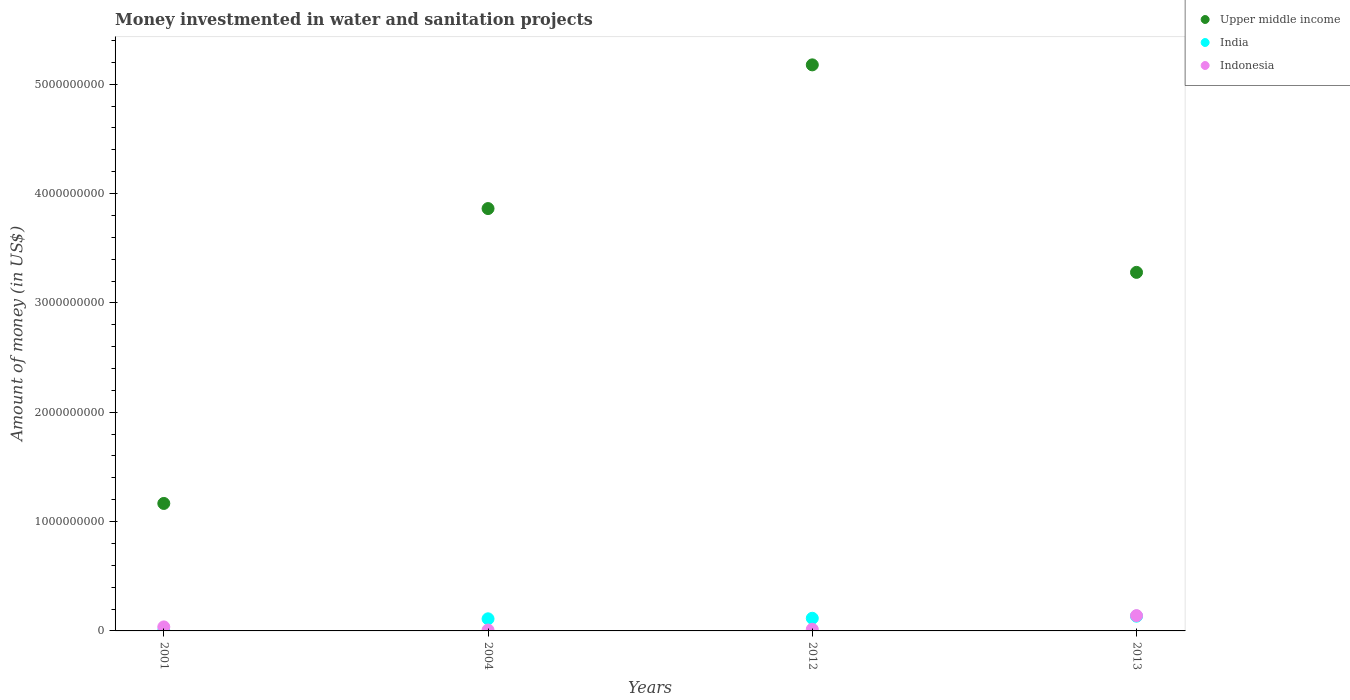How many different coloured dotlines are there?
Offer a very short reply. 3. Is the number of dotlines equal to the number of legend labels?
Your answer should be very brief. Yes. What is the money investmented in water and sanitation projects in India in 2001?
Offer a very short reply. 2.10e+06. Across all years, what is the maximum money investmented in water and sanitation projects in India?
Keep it short and to the point. 1.35e+08. Across all years, what is the minimum money investmented in water and sanitation projects in Upper middle income?
Keep it short and to the point. 1.17e+09. In which year was the money investmented in water and sanitation projects in Indonesia minimum?
Keep it short and to the point. 2004. What is the total money investmented in water and sanitation projects in Indonesia in the graph?
Ensure brevity in your answer.  2.00e+08. What is the difference between the money investmented in water and sanitation projects in Indonesia in 2012 and that in 2013?
Give a very brief answer. -1.25e+08. What is the difference between the money investmented in water and sanitation projects in India in 2004 and the money investmented in water and sanitation projects in Indonesia in 2012?
Your answer should be very brief. 9.58e+07. What is the average money investmented in water and sanitation projects in India per year?
Your answer should be very brief. 9.09e+07. In the year 2013, what is the difference between the money investmented in water and sanitation projects in India and money investmented in water and sanitation projects in Indonesia?
Ensure brevity in your answer.  -4.90e+06. In how many years, is the money investmented in water and sanitation projects in India greater than 2600000000 US$?
Provide a succinct answer. 0. What is the ratio of the money investmented in water and sanitation projects in India in 2004 to that in 2012?
Offer a terse response. 0.96. Is the difference between the money investmented in water and sanitation projects in India in 2001 and 2012 greater than the difference between the money investmented in water and sanitation projects in Indonesia in 2001 and 2012?
Your answer should be very brief. No. What is the difference between the highest and the second highest money investmented in water and sanitation projects in India?
Give a very brief answer. 1.95e+07. What is the difference between the highest and the lowest money investmented in water and sanitation projects in India?
Give a very brief answer. 1.33e+08. Is the sum of the money investmented in water and sanitation projects in Upper middle income in 2004 and 2013 greater than the maximum money investmented in water and sanitation projects in Indonesia across all years?
Provide a succinct answer. Yes. Does the money investmented in water and sanitation projects in Indonesia monotonically increase over the years?
Make the answer very short. No. Is the money investmented in water and sanitation projects in India strictly greater than the money investmented in water and sanitation projects in Indonesia over the years?
Your answer should be very brief. No. Is the money investmented in water and sanitation projects in India strictly less than the money investmented in water and sanitation projects in Indonesia over the years?
Ensure brevity in your answer.  No. How many dotlines are there?
Provide a short and direct response. 3. How many years are there in the graph?
Offer a terse response. 4. Are the values on the major ticks of Y-axis written in scientific E-notation?
Your response must be concise. No. Does the graph contain grids?
Offer a terse response. No. What is the title of the graph?
Your response must be concise. Money investmented in water and sanitation projects. Does "Honduras" appear as one of the legend labels in the graph?
Your response must be concise. No. What is the label or title of the Y-axis?
Your response must be concise. Amount of money (in US$). What is the Amount of money (in US$) of Upper middle income in 2001?
Your response must be concise. 1.17e+09. What is the Amount of money (in US$) in India in 2001?
Make the answer very short. 2.10e+06. What is the Amount of money (in US$) of Indonesia in 2001?
Make the answer very short. 3.67e+07. What is the Amount of money (in US$) in Upper middle income in 2004?
Keep it short and to the point. 3.86e+09. What is the Amount of money (in US$) of India in 2004?
Your answer should be compact. 1.11e+08. What is the Amount of money (in US$) of Indonesia in 2004?
Your answer should be compact. 8.10e+06. What is the Amount of money (in US$) of Upper middle income in 2012?
Your answer should be very brief. 5.18e+09. What is the Amount of money (in US$) of India in 2012?
Keep it short and to the point. 1.16e+08. What is the Amount of money (in US$) of Indonesia in 2012?
Your response must be concise. 1.50e+07. What is the Amount of money (in US$) of Upper middle income in 2013?
Make the answer very short. 3.28e+09. What is the Amount of money (in US$) in India in 2013?
Your answer should be very brief. 1.35e+08. What is the Amount of money (in US$) in Indonesia in 2013?
Make the answer very short. 1.40e+08. Across all years, what is the maximum Amount of money (in US$) in Upper middle income?
Offer a very short reply. 5.18e+09. Across all years, what is the maximum Amount of money (in US$) in India?
Your answer should be very brief. 1.35e+08. Across all years, what is the maximum Amount of money (in US$) of Indonesia?
Provide a succinct answer. 1.40e+08. Across all years, what is the minimum Amount of money (in US$) in Upper middle income?
Your response must be concise. 1.17e+09. Across all years, what is the minimum Amount of money (in US$) in India?
Make the answer very short. 2.10e+06. Across all years, what is the minimum Amount of money (in US$) in Indonesia?
Provide a short and direct response. 8.10e+06. What is the total Amount of money (in US$) of Upper middle income in the graph?
Offer a very short reply. 1.35e+1. What is the total Amount of money (in US$) of India in the graph?
Give a very brief answer. 3.64e+08. What is the total Amount of money (in US$) in Indonesia in the graph?
Your response must be concise. 2.00e+08. What is the difference between the Amount of money (in US$) of Upper middle income in 2001 and that in 2004?
Provide a short and direct response. -2.70e+09. What is the difference between the Amount of money (in US$) of India in 2001 and that in 2004?
Keep it short and to the point. -1.09e+08. What is the difference between the Amount of money (in US$) in Indonesia in 2001 and that in 2004?
Provide a succinct answer. 2.86e+07. What is the difference between the Amount of money (in US$) in Upper middle income in 2001 and that in 2012?
Your answer should be very brief. -4.01e+09. What is the difference between the Amount of money (in US$) of India in 2001 and that in 2012?
Offer a terse response. -1.14e+08. What is the difference between the Amount of money (in US$) of Indonesia in 2001 and that in 2012?
Offer a terse response. 2.17e+07. What is the difference between the Amount of money (in US$) in Upper middle income in 2001 and that in 2013?
Give a very brief answer. -2.11e+09. What is the difference between the Amount of money (in US$) of India in 2001 and that in 2013?
Your answer should be compact. -1.33e+08. What is the difference between the Amount of money (in US$) of Indonesia in 2001 and that in 2013?
Make the answer very short. -1.03e+08. What is the difference between the Amount of money (in US$) in Upper middle income in 2004 and that in 2012?
Ensure brevity in your answer.  -1.31e+09. What is the difference between the Amount of money (in US$) in India in 2004 and that in 2012?
Provide a short and direct response. -4.85e+06. What is the difference between the Amount of money (in US$) of Indonesia in 2004 and that in 2012?
Provide a succinct answer. -6.90e+06. What is the difference between the Amount of money (in US$) in Upper middle income in 2004 and that in 2013?
Your response must be concise. 5.83e+08. What is the difference between the Amount of money (in US$) of India in 2004 and that in 2013?
Ensure brevity in your answer.  -2.44e+07. What is the difference between the Amount of money (in US$) in Indonesia in 2004 and that in 2013?
Offer a terse response. -1.32e+08. What is the difference between the Amount of money (in US$) of Upper middle income in 2012 and that in 2013?
Provide a succinct answer. 1.90e+09. What is the difference between the Amount of money (in US$) in India in 2012 and that in 2013?
Your response must be concise. -1.95e+07. What is the difference between the Amount of money (in US$) in Indonesia in 2012 and that in 2013?
Offer a very short reply. -1.25e+08. What is the difference between the Amount of money (in US$) in Upper middle income in 2001 and the Amount of money (in US$) in India in 2004?
Keep it short and to the point. 1.06e+09. What is the difference between the Amount of money (in US$) in Upper middle income in 2001 and the Amount of money (in US$) in Indonesia in 2004?
Your response must be concise. 1.16e+09. What is the difference between the Amount of money (in US$) in India in 2001 and the Amount of money (in US$) in Indonesia in 2004?
Make the answer very short. -6.00e+06. What is the difference between the Amount of money (in US$) in Upper middle income in 2001 and the Amount of money (in US$) in India in 2012?
Provide a short and direct response. 1.05e+09. What is the difference between the Amount of money (in US$) of Upper middle income in 2001 and the Amount of money (in US$) of Indonesia in 2012?
Offer a terse response. 1.15e+09. What is the difference between the Amount of money (in US$) of India in 2001 and the Amount of money (in US$) of Indonesia in 2012?
Keep it short and to the point. -1.29e+07. What is the difference between the Amount of money (in US$) of Upper middle income in 2001 and the Amount of money (in US$) of India in 2013?
Keep it short and to the point. 1.03e+09. What is the difference between the Amount of money (in US$) of Upper middle income in 2001 and the Amount of money (in US$) of Indonesia in 2013?
Offer a terse response. 1.03e+09. What is the difference between the Amount of money (in US$) of India in 2001 and the Amount of money (in US$) of Indonesia in 2013?
Make the answer very short. -1.38e+08. What is the difference between the Amount of money (in US$) in Upper middle income in 2004 and the Amount of money (in US$) in India in 2012?
Offer a terse response. 3.75e+09. What is the difference between the Amount of money (in US$) in Upper middle income in 2004 and the Amount of money (in US$) in Indonesia in 2012?
Offer a terse response. 3.85e+09. What is the difference between the Amount of money (in US$) of India in 2004 and the Amount of money (in US$) of Indonesia in 2012?
Make the answer very short. 9.58e+07. What is the difference between the Amount of money (in US$) of Upper middle income in 2004 and the Amount of money (in US$) of India in 2013?
Your answer should be compact. 3.73e+09. What is the difference between the Amount of money (in US$) in Upper middle income in 2004 and the Amount of money (in US$) in Indonesia in 2013?
Your answer should be compact. 3.72e+09. What is the difference between the Amount of money (in US$) of India in 2004 and the Amount of money (in US$) of Indonesia in 2013?
Give a very brief answer. -2.92e+07. What is the difference between the Amount of money (in US$) in Upper middle income in 2012 and the Amount of money (in US$) in India in 2013?
Your answer should be compact. 5.04e+09. What is the difference between the Amount of money (in US$) in Upper middle income in 2012 and the Amount of money (in US$) in Indonesia in 2013?
Make the answer very short. 5.04e+09. What is the difference between the Amount of money (in US$) in India in 2012 and the Amount of money (in US$) in Indonesia in 2013?
Give a very brief answer. -2.44e+07. What is the average Amount of money (in US$) of Upper middle income per year?
Give a very brief answer. 3.37e+09. What is the average Amount of money (in US$) in India per year?
Your response must be concise. 9.09e+07. What is the average Amount of money (in US$) in Indonesia per year?
Offer a very short reply. 5.00e+07. In the year 2001, what is the difference between the Amount of money (in US$) of Upper middle income and Amount of money (in US$) of India?
Your answer should be very brief. 1.16e+09. In the year 2001, what is the difference between the Amount of money (in US$) in Upper middle income and Amount of money (in US$) in Indonesia?
Offer a very short reply. 1.13e+09. In the year 2001, what is the difference between the Amount of money (in US$) of India and Amount of money (in US$) of Indonesia?
Your answer should be compact. -3.46e+07. In the year 2004, what is the difference between the Amount of money (in US$) of Upper middle income and Amount of money (in US$) of India?
Your response must be concise. 3.75e+09. In the year 2004, what is the difference between the Amount of money (in US$) of Upper middle income and Amount of money (in US$) of Indonesia?
Give a very brief answer. 3.85e+09. In the year 2004, what is the difference between the Amount of money (in US$) of India and Amount of money (in US$) of Indonesia?
Provide a succinct answer. 1.03e+08. In the year 2012, what is the difference between the Amount of money (in US$) of Upper middle income and Amount of money (in US$) of India?
Provide a short and direct response. 5.06e+09. In the year 2012, what is the difference between the Amount of money (in US$) of Upper middle income and Amount of money (in US$) of Indonesia?
Offer a very short reply. 5.16e+09. In the year 2012, what is the difference between the Amount of money (in US$) in India and Amount of money (in US$) in Indonesia?
Give a very brief answer. 1.01e+08. In the year 2013, what is the difference between the Amount of money (in US$) of Upper middle income and Amount of money (in US$) of India?
Provide a succinct answer. 3.14e+09. In the year 2013, what is the difference between the Amount of money (in US$) in Upper middle income and Amount of money (in US$) in Indonesia?
Make the answer very short. 3.14e+09. In the year 2013, what is the difference between the Amount of money (in US$) in India and Amount of money (in US$) in Indonesia?
Offer a very short reply. -4.90e+06. What is the ratio of the Amount of money (in US$) in Upper middle income in 2001 to that in 2004?
Your answer should be compact. 0.3. What is the ratio of the Amount of money (in US$) of India in 2001 to that in 2004?
Your response must be concise. 0.02. What is the ratio of the Amount of money (in US$) of Indonesia in 2001 to that in 2004?
Provide a succinct answer. 4.53. What is the ratio of the Amount of money (in US$) of Upper middle income in 2001 to that in 2012?
Offer a terse response. 0.23. What is the ratio of the Amount of money (in US$) of India in 2001 to that in 2012?
Offer a very short reply. 0.02. What is the ratio of the Amount of money (in US$) in Indonesia in 2001 to that in 2012?
Keep it short and to the point. 2.45. What is the ratio of the Amount of money (in US$) of Upper middle income in 2001 to that in 2013?
Your answer should be compact. 0.36. What is the ratio of the Amount of money (in US$) of India in 2001 to that in 2013?
Ensure brevity in your answer.  0.02. What is the ratio of the Amount of money (in US$) of Indonesia in 2001 to that in 2013?
Ensure brevity in your answer.  0.26. What is the ratio of the Amount of money (in US$) in Upper middle income in 2004 to that in 2012?
Offer a very short reply. 0.75. What is the ratio of the Amount of money (in US$) of India in 2004 to that in 2012?
Give a very brief answer. 0.96. What is the ratio of the Amount of money (in US$) of Indonesia in 2004 to that in 2012?
Offer a very short reply. 0.54. What is the ratio of the Amount of money (in US$) of Upper middle income in 2004 to that in 2013?
Your response must be concise. 1.18. What is the ratio of the Amount of money (in US$) in India in 2004 to that in 2013?
Give a very brief answer. 0.82. What is the ratio of the Amount of money (in US$) of Indonesia in 2004 to that in 2013?
Keep it short and to the point. 0.06. What is the ratio of the Amount of money (in US$) in Upper middle income in 2012 to that in 2013?
Ensure brevity in your answer.  1.58. What is the ratio of the Amount of money (in US$) in India in 2012 to that in 2013?
Give a very brief answer. 0.86. What is the ratio of the Amount of money (in US$) of Indonesia in 2012 to that in 2013?
Give a very brief answer. 0.11. What is the difference between the highest and the second highest Amount of money (in US$) of Upper middle income?
Your answer should be very brief. 1.31e+09. What is the difference between the highest and the second highest Amount of money (in US$) of India?
Give a very brief answer. 1.95e+07. What is the difference between the highest and the second highest Amount of money (in US$) of Indonesia?
Keep it short and to the point. 1.03e+08. What is the difference between the highest and the lowest Amount of money (in US$) of Upper middle income?
Your answer should be very brief. 4.01e+09. What is the difference between the highest and the lowest Amount of money (in US$) of India?
Ensure brevity in your answer.  1.33e+08. What is the difference between the highest and the lowest Amount of money (in US$) of Indonesia?
Your response must be concise. 1.32e+08. 